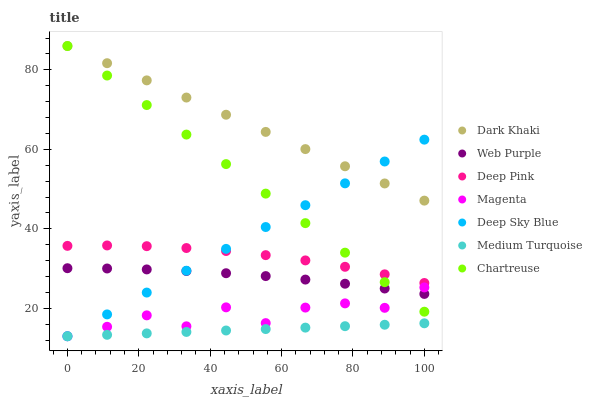Does Medium Turquoise have the minimum area under the curve?
Answer yes or no. Yes. Does Dark Khaki have the maximum area under the curve?
Answer yes or no. Yes. Does Chartreuse have the minimum area under the curve?
Answer yes or no. No. Does Chartreuse have the maximum area under the curve?
Answer yes or no. No. Is Medium Turquoise the smoothest?
Answer yes or no. Yes. Is Magenta the roughest?
Answer yes or no. Yes. Is Chartreuse the smoothest?
Answer yes or no. No. Is Chartreuse the roughest?
Answer yes or no. No. Does Medium Turquoise have the lowest value?
Answer yes or no. Yes. Does Chartreuse have the lowest value?
Answer yes or no. No. Does Dark Khaki have the highest value?
Answer yes or no. Yes. Does Medium Turquoise have the highest value?
Answer yes or no. No. Is Web Purple less than Dark Khaki?
Answer yes or no. Yes. Is Dark Khaki greater than Magenta?
Answer yes or no. Yes. Does Deep Pink intersect Deep Sky Blue?
Answer yes or no. Yes. Is Deep Pink less than Deep Sky Blue?
Answer yes or no. No. Is Deep Pink greater than Deep Sky Blue?
Answer yes or no. No. Does Web Purple intersect Dark Khaki?
Answer yes or no. No. 